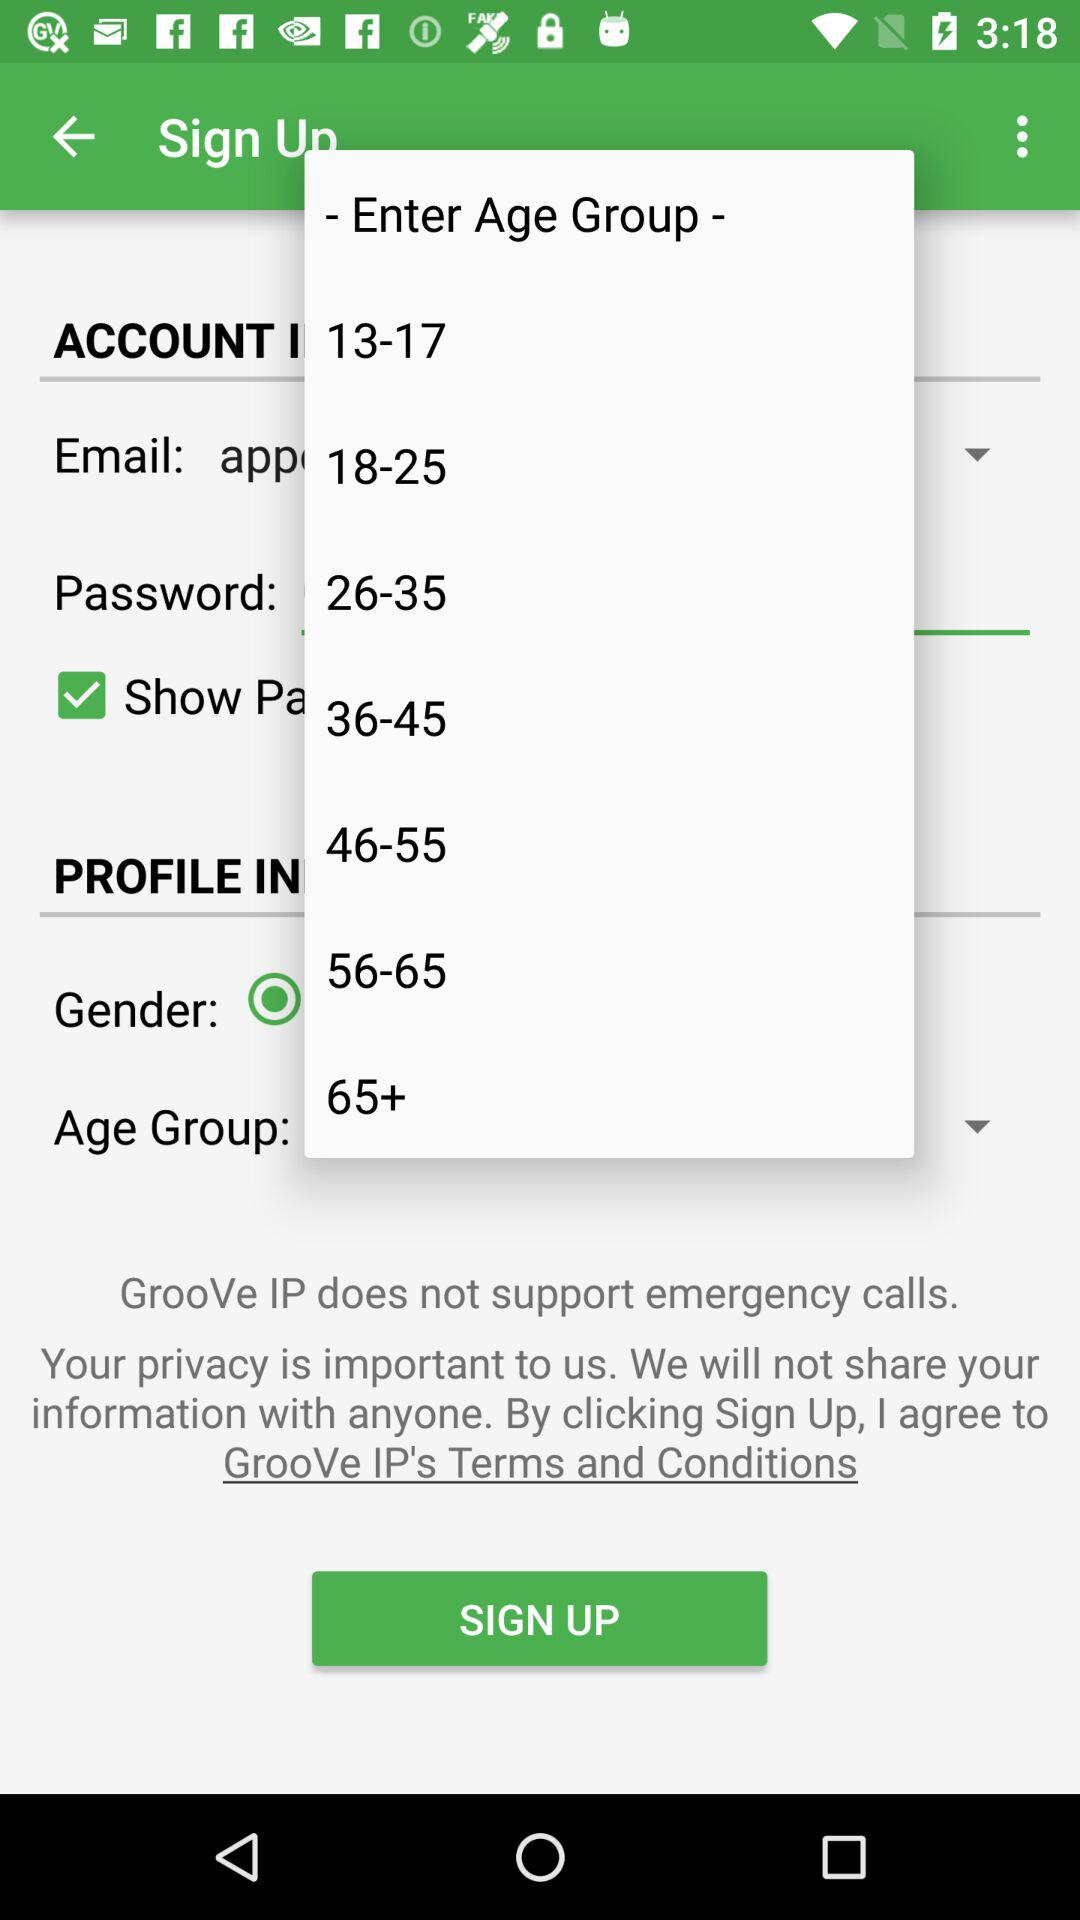How many age groups are there?
Answer the question using a single word or phrase. 7 